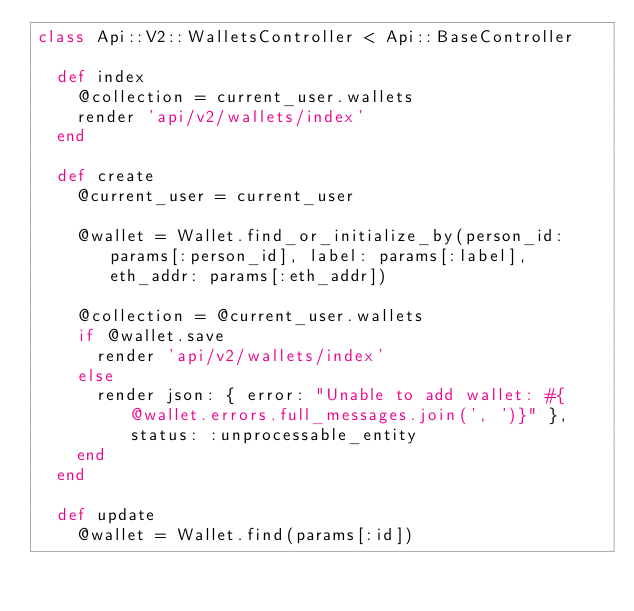<code> <loc_0><loc_0><loc_500><loc_500><_Ruby_>class Api::V2::WalletsController < Api::BaseController

  def index
    @collection = current_user.wallets
    render 'api/v2/wallets/index'
  end

  def create
    @current_user = current_user
    
    @wallet = Wallet.find_or_initialize_by(person_id: params[:person_id], label: params[:label], eth_addr: params[:eth_addr])

    @collection = @current_user.wallets
    if @wallet.save
      render 'api/v2/wallets/index'
    else
      render json: { error: "Unable to add wallet: #{@wallet.errors.full_messages.join(', ')}" }, status: :unprocessable_entity
    end
  end

  def update
    @wallet = Wallet.find(params[:id])</code> 